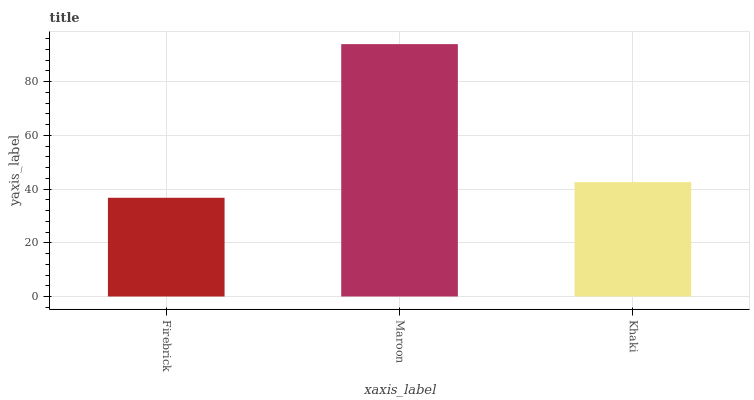Is Firebrick the minimum?
Answer yes or no. Yes. Is Maroon the maximum?
Answer yes or no. Yes. Is Khaki the minimum?
Answer yes or no. No. Is Khaki the maximum?
Answer yes or no. No. Is Maroon greater than Khaki?
Answer yes or no. Yes. Is Khaki less than Maroon?
Answer yes or no. Yes. Is Khaki greater than Maroon?
Answer yes or no. No. Is Maroon less than Khaki?
Answer yes or no. No. Is Khaki the high median?
Answer yes or no. Yes. Is Khaki the low median?
Answer yes or no. Yes. Is Maroon the high median?
Answer yes or no. No. Is Firebrick the low median?
Answer yes or no. No. 